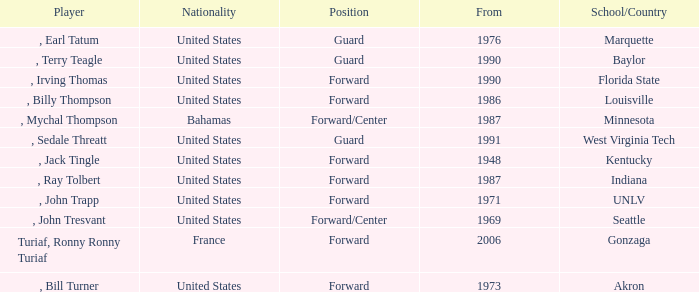What was the nationality of all players from the year 1976? United States. 